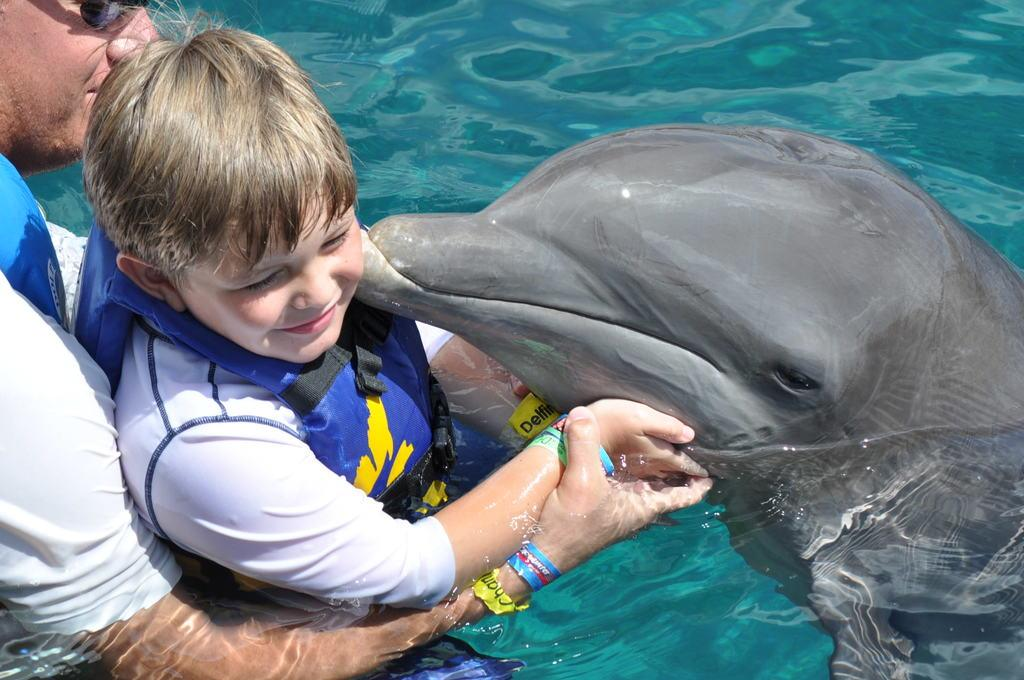Where is the image taken? The image is taken in a pool. Who is present in the image? There is a man in the image. What is the man doing in the image? The man is holding a boy in his hands. What else can be seen in the image? There is a shark in the image. What is the primary element in the image? There is water visible in the image. Reasoning: Let's think step by step by following the given facts step by step to produce the conversation. We start by identifying the location of the image, which is a pool. Then, we mention the people present in the image, specifically the man holding a boy. Next, we acknowledge the presence of a shark in the image, which adds an interesting element to the scene. Finally, we describe the primary element in the image, which is water. Absurd Question/Answer: What type of trees can be seen in the image? There are no trees present in the image; it is taken in a pool. What class is the man teaching in the image? There is no indication of a class or teaching in the image; the man is holding a boy in his hands. 